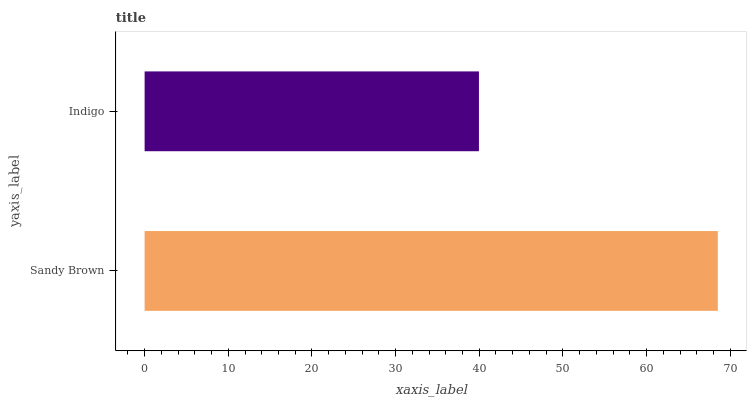Is Indigo the minimum?
Answer yes or no. Yes. Is Sandy Brown the maximum?
Answer yes or no. Yes. Is Indigo the maximum?
Answer yes or no. No. Is Sandy Brown greater than Indigo?
Answer yes or no. Yes. Is Indigo less than Sandy Brown?
Answer yes or no. Yes. Is Indigo greater than Sandy Brown?
Answer yes or no. No. Is Sandy Brown less than Indigo?
Answer yes or no. No. Is Sandy Brown the high median?
Answer yes or no. Yes. Is Indigo the low median?
Answer yes or no. Yes. Is Indigo the high median?
Answer yes or no. No. Is Sandy Brown the low median?
Answer yes or no. No. 